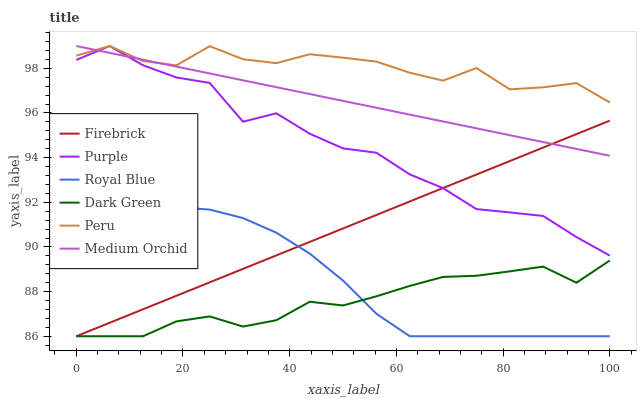Does Dark Green have the minimum area under the curve?
Answer yes or no. Yes. Does Peru have the maximum area under the curve?
Answer yes or no. Yes. Does Firebrick have the minimum area under the curve?
Answer yes or no. No. Does Firebrick have the maximum area under the curve?
Answer yes or no. No. Is Medium Orchid the smoothest?
Answer yes or no. Yes. Is Purple the roughest?
Answer yes or no. Yes. Is Firebrick the smoothest?
Answer yes or no. No. Is Firebrick the roughest?
Answer yes or no. No. Does Firebrick have the lowest value?
Answer yes or no. Yes. Does Medium Orchid have the lowest value?
Answer yes or no. No. Does Peru have the highest value?
Answer yes or no. Yes. Does Firebrick have the highest value?
Answer yes or no. No. Is Royal Blue less than Purple?
Answer yes or no. Yes. Is Peru greater than Royal Blue?
Answer yes or no. Yes. Does Firebrick intersect Royal Blue?
Answer yes or no. Yes. Is Firebrick less than Royal Blue?
Answer yes or no. No. Is Firebrick greater than Royal Blue?
Answer yes or no. No. Does Royal Blue intersect Purple?
Answer yes or no. No. 